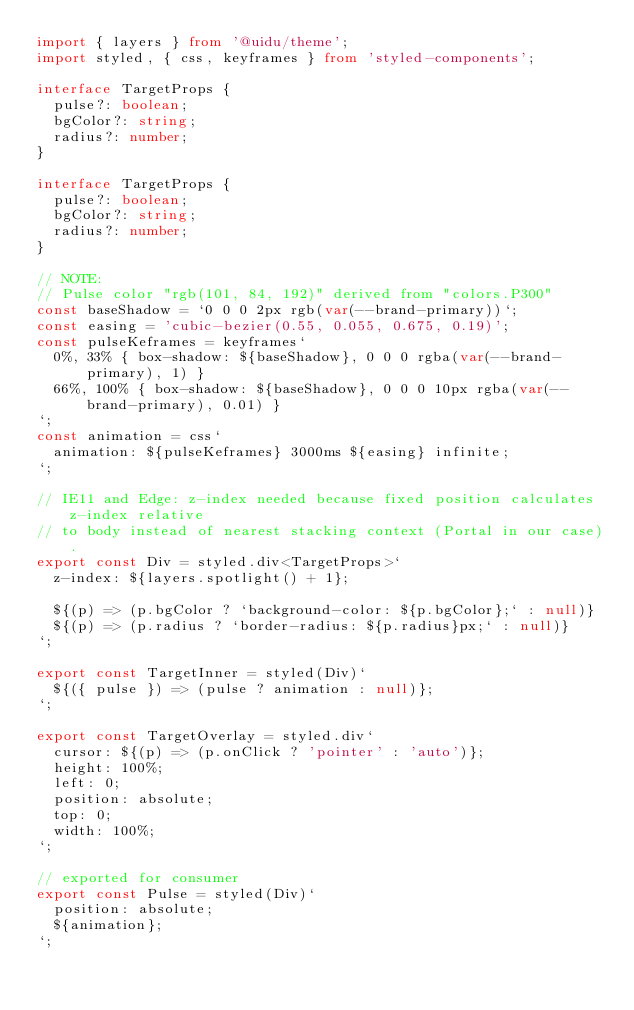<code> <loc_0><loc_0><loc_500><loc_500><_TypeScript_>import { layers } from '@uidu/theme';
import styled, { css, keyframes } from 'styled-components';

interface TargetProps {
  pulse?: boolean;
  bgColor?: string;
  radius?: number;
}

interface TargetProps {
  pulse?: boolean;
  bgColor?: string;
  radius?: number;
}

// NOTE:
// Pulse color "rgb(101, 84, 192)" derived from "colors.P300"
const baseShadow = `0 0 0 2px rgb(var(--brand-primary))`;
const easing = 'cubic-bezier(0.55, 0.055, 0.675, 0.19)';
const pulseKeframes = keyframes`
  0%, 33% { box-shadow: ${baseShadow}, 0 0 0 rgba(var(--brand-primary), 1) }
  66%, 100% { box-shadow: ${baseShadow}, 0 0 0 10px rgba(var(--brand-primary), 0.01) }
`;
const animation = css`
  animation: ${pulseKeframes} 3000ms ${easing} infinite;
`;

// IE11 and Edge: z-index needed because fixed position calculates z-index relative
// to body instead of nearest stacking context (Portal in our case).
export const Div = styled.div<TargetProps>`
  z-index: ${layers.spotlight() + 1};

  ${(p) => (p.bgColor ? `background-color: ${p.bgColor};` : null)}
  ${(p) => (p.radius ? `border-radius: ${p.radius}px;` : null)}
`;

export const TargetInner = styled(Div)`
  ${({ pulse }) => (pulse ? animation : null)};
`;

export const TargetOverlay = styled.div`
  cursor: ${(p) => (p.onClick ? 'pointer' : 'auto')};
  height: 100%;
  left: 0;
  position: absolute;
  top: 0;
  width: 100%;
`;

// exported for consumer
export const Pulse = styled(Div)`
  position: absolute;
  ${animation};
`;
</code> 